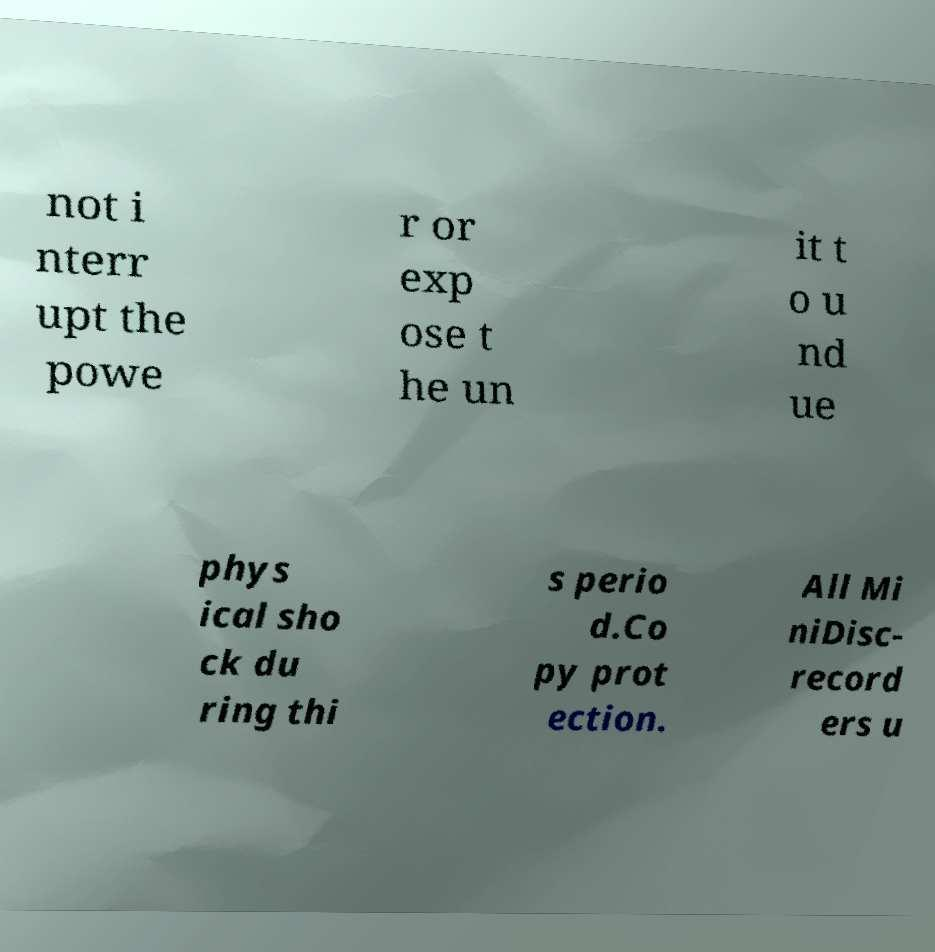Please read and relay the text visible in this image. What does it say? not i nterr upt the powe r or exp ose t he un it t o u nd ue phys ical sho ck du ring thi s perio d.Co py prot ection. All Mi niDisc- record ers u 